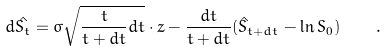<formula> <loc_0><loc_0><loc_500><loc_500>d \hat { S _ { t } } = \sigma \sqrt { \frac { t } { t + d t } d t } \cdot z - \frac { d t } { t + d t } ( \hat { S } _ { t + d t } - \ln S _ { 0 } ) \quad .</formula> 